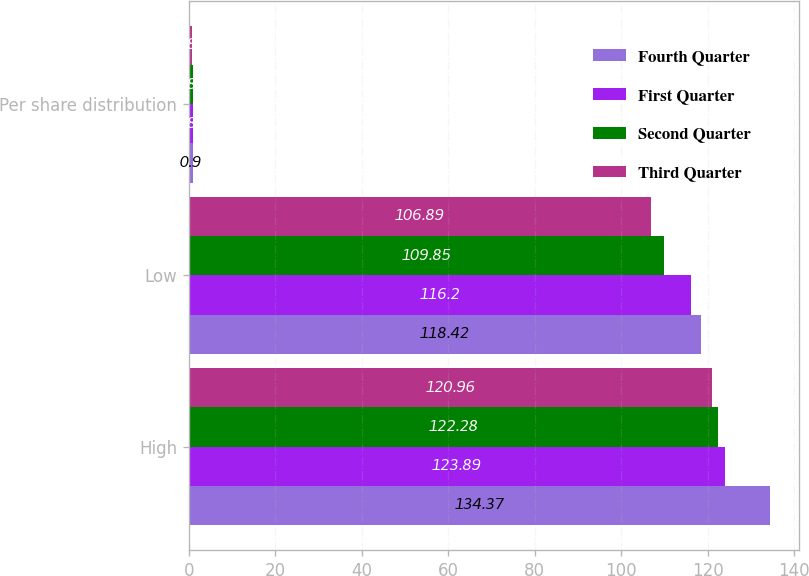<chart> <loc_0><loc_0><loc_500><loc_500><stacked_bar_chart><ecel><fcel>High<fcel>Low<fcel>Per share distribution<nl><fcel>Fourth Quarter<fcel>134.37<fcel>118.42<fcel>0.9<nl><fcel>First Quarter<fcel>123.89<fcel>116.2<fcel>0.86<nl><fcel>Second Quarter<fcel>122.28<fcel>109.85<fcel>0.86<nl><fcel>Third Quarter<fcel>120.96<fcel>106.89<fcel>0.83<nl></chart> 